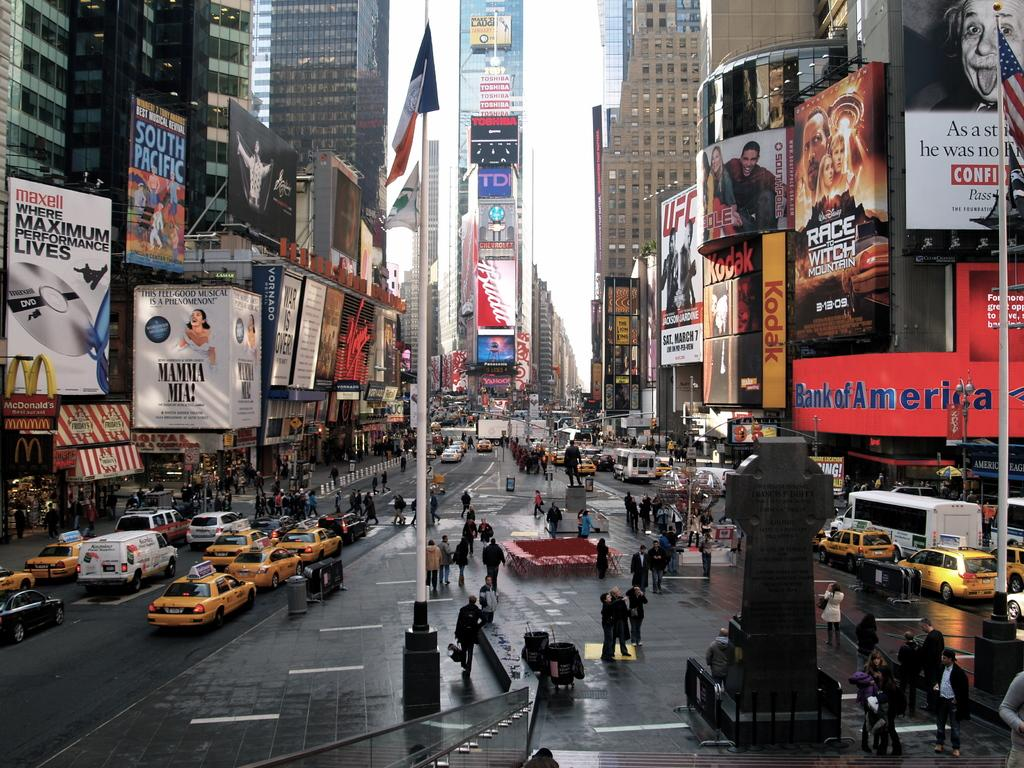<image>
Render a clear and concise summary of the photo. A busy city street has many stores and advertisements, including Bank of America, Maxell DVD, and Mamma Mia! 